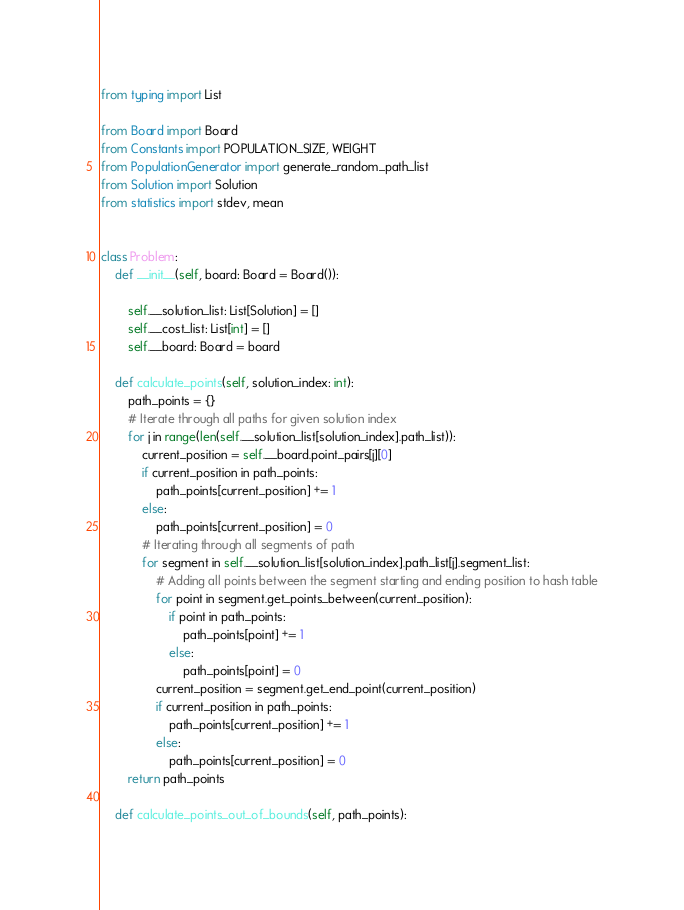Convert code to text. <code><loc_0><loc_0><loc_500><loc_500><_Python_>from typing import List

from Board import Board
from Constants import POPULATION_SIZE, WEIGHT
from PopulationGenerator import generate_random_path_list
from Solution import Solution
from statistics import stdev, mean


class Problem:
    def __init__(self, board: Board = Board()):

        self.__solution_list: List[Solution] = []
        self.__cost_list: List[int] = []
        self.__board: Board = board

    def calculate_points(self, solution_index: int):
        path_points = {}
        # Iterate through all paths for given solution index
        for j in range(len(self.__solution_list[solution_index].path_list)):
            current_position = self.__board.point_pairs[j][0]
            if current_position in path_points:
                path_points[current_position] += 1
            else:
                path_points[current_position] = 0
            # Iterating through all segments of path
            for segment in self.__solution_list[solution_index].path_list[j].segment_list:
                # Adding all points between the segment starting and ending position to hash table
                for point in segment.get_points_between(current_position):
                    if point in path_points:
                        path_points[point] += 1
                    else:
                        path_points[point] = 0
                current_position = segment.get_end_point(current_position)
                if current_position in path_points:
                    path_points[current_position] += 1
                else:
                    path_points[current_position] = 0
        return path_points

    def calculate_points_out_of_bounds(self, path_points):</code> 